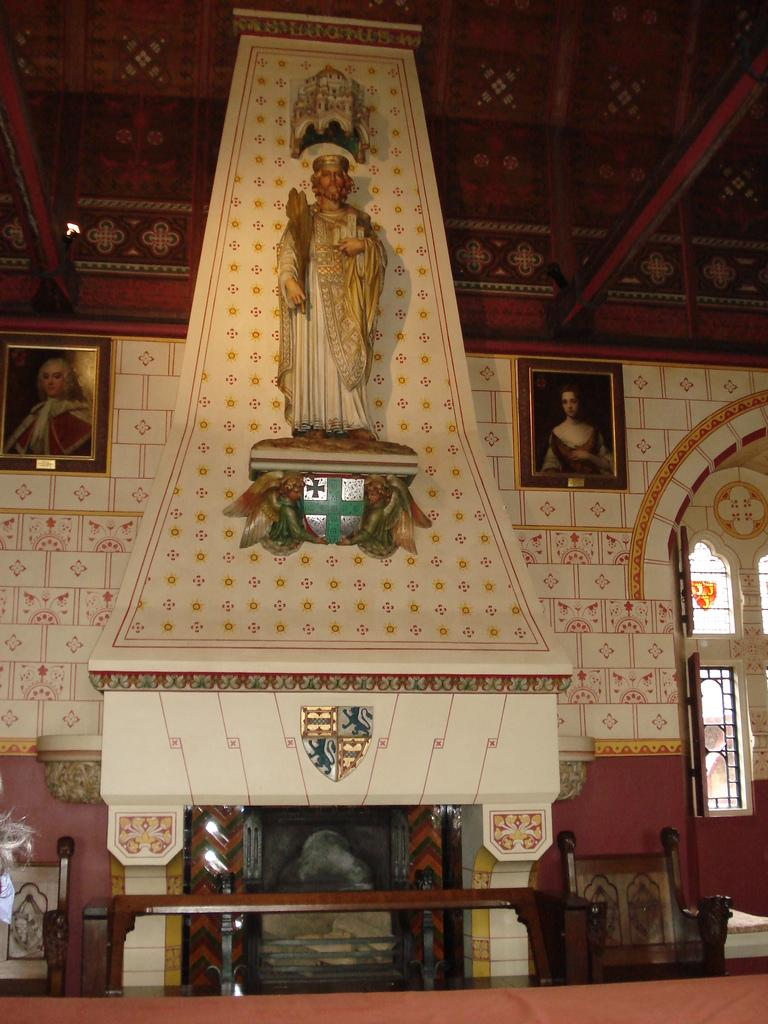What type of location is depicted in the image? The image is an inside view of a church. What can be seen on the walls of the church? There are frames placed on the wall in the image. Is there any furniture visible in the image? Yes, there is a chair in the image. What can be seen through the windows in the image? The windows in the image allow for natural light to enter the church. What type of decoration or art is present in the image? There is a statue in the image. What is visible at the top of the image? The roof is visible at the top of the image. What type of owl can be seen sitting on the chair in the image? There is no owl present in the image; it is an inside view of a church with no animals visible. 